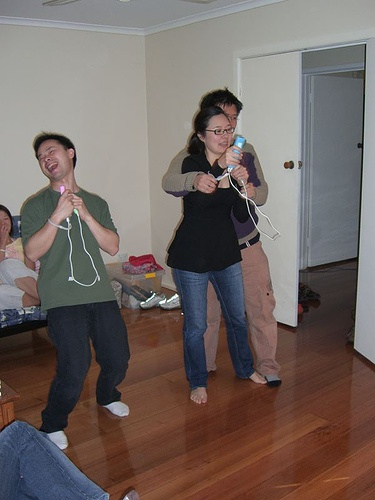Describe the objects in this image and their specific colors. I can see people in gray, black, and darkgray tones, people in gray, black, and navy tones, people in gray, black, and darkgray tones, people in gray, darkblue, blue, and navy tones, and people in gray, darkgray, brown, and black tones in this image. 